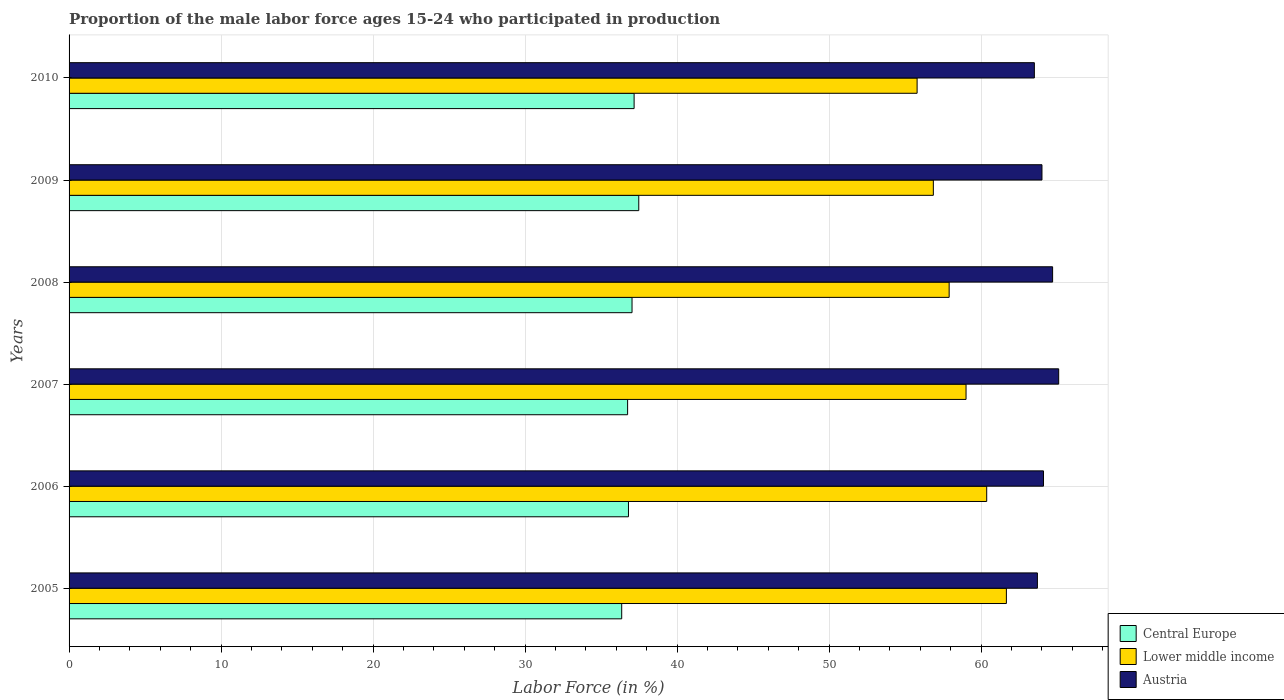How many different coloured bars are there?
Ensure brevity in your answer.  3. How many bars are there on the 5th tick from the top?
Provide a succinct answer. 3. What is the label of the 6th group of bars from the top?
Provide a short and direct response. 2005. In how many cases, is the number of bars for a given year not equal to the number of legend labels?
Offer a very short reply. 0. What is the proportion of the male labor force who participated in production in Lower middle income in 2010?
Your answer should be very brief. 55.79. Across all years, what is the maximum proportion of the male labor force who participated in production in Central Europe?
Make the answer very short. 37.48. Across all years, what is the minimum proportion of the male labor force who participated in production in Austria?
Keep it short and to the point. 63.5. In which year was the proportion of the male labor force who participated in production in Central Europe maximum?
Your response must be concise. 2009. In which year was the proportion of the male labor force who participated in production in Central Europe minimum?
Keep it short and to the point. 2005. What is the total proportion of the male labor force who participated in production in Austria in the graph?
Provide a succinct answer. 385.1. What is the difference between the proportion of the male labor force who participated in production in Lower middle income in 2006 and that in 2009?
Offer a very short reply. 3.51. What is the difference between the proportion of the male labor force who participated in production in Lower middle income in 2006 and the proportion of the male labor force who participated in production in Central Europe in 2008?
Provide a succinct answer. 23.33. What is the average proportion of the male labor force who participated in production in Austria per year?
Your answer should be compact. 64.18. In the year 2006, what is the difference between the proportion of the male labor force who participated in production in Central Europe and proportion of the male labor force who participated in production in Austria?
Ensure brevity in your answer.  -27.3. In how many years, is the proportion of the male labor force who participated in production in Lower middle income greater than 38 %?
Your answer should be compact. 6. What is the ratio of the proportion of the male labor force who participated in production in Lower middle income in 2009 to that in 2010?
Provide a succinct answer. 1.02. Is the difference between the proportion of the male labor force who participated in production in Central Europe in 2005 and 2006 greater than the difference between the proportion of the male labor force who participated in production in Austria in 2005 and 2006?
Offer a very short reply. No. What is the difference between the highest and the second highest proportion of the male labor force who participated in production in Central Europe?
Provide a short and direct response. 0.31. What is the difference between the highest and the lowest proportion of the male labor force who participated in production in Lower middle income?
Offer a very short reply. 5.87. Is the sum of the proportion of the male labor force who participated in production in Austria in 2008 and 2009 greater than the maximum proportion of the male labor force who participated in production in Central Europe across all years?
Provide a succinct answer. Yes. What does the 1st bar from the top in 2010 represents?
Make the answer very short. Austria. What does the 1st bar from the bottom in 2007 represents?
Offer a very short reply. Central Europe. How many bars are there?
Your response must be concise. 18. How many years are there in the graph?
Offer a very short reply. 6. What is the difference between two consecutive major ticks on the X-axis?
Offer a very short reply. 10. What is the title of the graph?
Ensure brevity in your answer.  Proportion of the male labor force ages 15-24 who participated in production. What is the label or title of the X-axis?
Give a very brief answer. Labor Force (in %). What is the Labor Force (in %) of Central Europe in 2005?
Provide a succinct answer. 36.35. What is the Labor Force (in %) in Lower middle income in 2005?
Give a very brief answer. 61.66. What is the Labor Force (in %) in Austria in 2005?
Keep it short and to the point. 63.7. What is the Labor Force (in %) in Central Europe in 2006?
Make the answer very short. 36.8. What is the Labor Force (in %) in Lower middle income in 2006?
Offer a terse response. 60.37. What is the Labor Force (in %) of Austria in 2006?
Make the answer very short. 64.1. What is the Labor Force (in %) in Central Europe in 2007?
Offer a very short reply. 36.74. What is the Labor Force (in %) of Lower middle income in 2007?
Keep it short and to the point. 59.01. What is the Labor Force (in %) in Austria in 2007?
Ensure brevity in your answer.  65.1. What is the Labor Force (in %) in Central Europe in 2008?
Your answer should be compact. 37.03. What is the Labor Force (in %) of Lower middle income in 2008?
Your answer should be very brief. 57.9. What is the Labor Force (in %) in Austria in 2008?
Your answer should be very brief. 64.7. What is the Labor Force (in %) in Central Europe in 2009?
Provide a succinct answer. 37.48. What is the Labor Force (in %) of Lower middle income in 2009?
Make the answer very short. 56.86. What is the Labor Force (in %) of Central Europe in 2010?
Your response must be concise. 37.17. What is the Labor Force (in %) in Lower middle income in 2010?
Keep it short and to the point. 55.79. What is the Labor Force (in %) of Austria in 2010?
Your answer should be very brief. 63.5. Across all years, what is the maximum Labor Force (in %) of Central Europe?
Your answer should be compact. 37.48. Across all years, what is the maximum Labor Force (in %) of Lower middle income?
Your answer should be compact. 61.66. Across all years, what is the maximum Labor Force (in %) of Austria?
Ensure brevity in your answer.  65.1. Across all years, what is the minimum Labor Force (in %) of Central Europe?
Ensure brevity in your answer.  36.35. Across all years, what is the minimum Labor Force (in %) in Lower middle income?
Your answer should be very brief. 55.79. Across all years, what is the minimum Labor Force (in %) of Austria?
Your answer should be compact. 63.5. What is the total Labor Force (in %) of Central Europe in the graph?
Keep it short and to the point. 221.58. What is the total Labor Force (in %) of Lower middle income in the graph?
Give a very brief answer. 351.57. What is the total Labor Force (in %) in Austria in the graph?
Keep it short and to the point. 385.1. What is the difference between the Labor Force (in %) in Central Europe in 2005 and that in 2006?
Ensure brevity in your answer.  -0.44. What is the difference between the Labor Force (in %) in Lower middle income in 2005 and that in 2006?
Your answer should be very brief. 1.29. What is the difference between the Labor Force (in %) of Central Europe in 2005 and that in 2007?
Ensure brevity in your answer.  -0.39. What is the difference between the Labor Force (in %) in Lower middle income in 2005 and that in 2007?
Provide a succinct answer. 2.65. What is the difference between the Labor Force (in %) of Central Europe in 2005 and that in 2008?
Your response must be concise. -0.68. What is the difference between the Labor Force (in %) of Lower middle income in 2005 and that in 2008?
Ensure brevity in your answer.  3.77. What is the difference between the Labor Force (in %) in Central Europe in 2005 and that in 2009?
Make the answer very short. -1.12. What is the difference between the Labor Force (in %) in Lower middle income in 2005 and that in 2009?
Your answer should be very brief. 4.81. What is the difference between the Labor Force (in %) of Austria in 2005 and that in 2009?
Offer a terse response. -0.3. What is the difference between the Labor Force (in %) in Central Europe in 2005 and that in 2010?
Ensure brevity in your answer.  -0.82. What is the difference between the Labor Force (in %) of Lower middle income in 2005 and that in 2010?
Offer a terse response. 5.87. What is the difference between the Labor Force (in %) in Central Europe in 2006 and that in 2007?
Your answer should be very brief. 0.06. What is the difference between the Labor Force (in %) in Lower middle income in 2006 and that in 2007?
Provide a succinct answer. 1.36. What is the difference between the Labor Force (in %) of Austria in 2006 and that in 2007?
Give a very brief answer. -1. What is the difference between the Labor Force (in %) of Central Europe in 2006 and that in 2008?
Your answer should be very brief. -0.23. What is the difference between the Labor Force (in %) in Lower middle income in 2006 and that in 2008?
Your answer should be compact. 2.47. What is the difference between the Labor Force (in %) of Austria in 2006 and that in 2008?
Provide a succinct answer. -0.6. What is the difference between the Labor Force (in %) of Central Europe in 2006 and that in 2009?
Your answer should be compact. -0.68. What is the difference between the Labor Force (in %) in Lower middle income in 2006 and that in 2009?
Provide a succinct answer. 3.51. What is the difference between the Labor Force (in %) in Central Europe in 2006 and that in 2010?
Provide a short and direct response. -0.37. What is the difference between the Labor Force (in %) in Lower middle income in 2006 and that in 2010?
Offer a terse response. 4.58. What is the difference between the Labor Force (in %) in Central Europe in 2007 and that in 2008?
Your answer should be very brief. -0.29. What is the difference between the Labor Force (in %) in Austria in 2007 and that in 2008?
Provide a succinct answer. 0.4. What is the difference between the Labor Force (in %) of Central Europe in 2007 and that in 2009?
Your answer should be compact. -0.73. What is the difference between the Labor Force (in %) of Lower middle income in 2007 and that in 2009?
Keep it short and to the point. 2.15. What is the difference between the Labor Force (in %) in Austria in 2007 and that in 2009?
Your answer should be compact. 1.1. What is the difference between the Labor Force (in %) in Central Europe in 2007 and that in 2010?
Ensure brevity in your answer.  -0.43. What is the difference between the Labor Force (in %) in Lower middle income in 2007 and that in 2010?
Offer a very short reply. 3.22. What is the difference between the Labor Force (in %) of Austria in 2007 and that in 2010?
Make the answer very short. 1.6. What is the difference between the Labor Force (in %) of Central Europe in 2008 and that in 2009?
Give a very brief answer. -0.44. What is the difference between the Labor Force (in %) in Austria in 2008 and that in 2009?
Your response must be concise. 0.7. What is the difference between the Labor Force (in %) in Central Europe in 2008 and that in 2010?
Offer a terse response. -0.14. What is the difference between the Labor Force (in %) of Lower middle income in 2008 and that in 2010?
Your answer should be very brief. 2.11. What is the difference between the Labor Force (in %) in Austria in 2008 and that in 2010?
Make the answer very short. 1.2. What is the difference between the Labor Force (in %) of Central Europe in 2009 and that in 2010?
Your response must be concise. 0.31. What is the difference between the Labor Force (in %) in Lower middle income in 2009 and that in 2010?
Offer a very short reply. 1.07. What is the difference between the Labor Force (in %) of Central Europe in 2005 and the Labor Force (in %) of Lower middle income in 2006?
Provide a succinct answer. -24.01. What is the difference between the Labor Force (in %) in Central Europe in 2005 and the Labor Force (in %) in Austria in 2006?
Make the answer very short. -27.75. What is the difference between the Labor Force (in %) in Lower middle income in 2005 and the Labor Force (in %) in Austria in 2006?
Your response must be concise. -2.44. What is the difference between the Labor Force (in %) in Central Europe in 2005 and the Labor Force (in %) in Lower middle income in 2007?
Provide a succinct answer. -22.65. What is the difference between the Labor Force (in %) in Central Europe in 2005 and the Labor Force (in %) in Austria in 2007?
Give a very brief answer. -28.75. What is the difference between the Labor Force (in %) of Lower middle income in 2005 and the Labor Force (in %) of Austria in 2007?
Give a very brief answer. -3.44. What is the difference between the Labor Force (in %) of Central Europe in 2005 and the Labor Force (in %) of Lower middle income in 2008?
Your response must be concise. -21.54. What is the difference between the Labor Force (in %) of Central Europe in 2005 and the Labor Force (in %) of Austria in 2008?
Provide a short and direct response. -28.35. What is the difference between the Labor Force (in %) in Lower middle income in 2005 and the Labor Force (in %) in Austria in 2008?
Make the answer very short. -3.04. What is the difference between the Labor Force (in %) in Central Europe in 2005 and the Labor Force (in %) in Lower middle income in 2009?
Keep it short and to the point. -20.5. What is the difference between the Labor Force (in %) in Central Europe in 2005 and the Labor Force (in %) in Austria in 2009?
Keep it short and to the point. -27.65. What is the difference between the Labor Force (in %) in Lower middle income in 2005 and the Labor Force (in %) in Austria in 2009?
Offer a terse response. -2.34. What is the difference between the Labor Force (in %) in Central Europe in 2005 and the Labor Force (in %) in Lower middle income in 2010?
Keep it short and to the point. -19.43. What is the difference between the Labor Force (in %) of Central Europe in 2005 and the Labor Force (in %) of Austria in 2010?
Provide a short and direct response. -27.15. What is the difference between the Labor Force (in %) in Lower middle income in 2005 and the Labor Force (in %) in Austria in 2010?
Give a very brief answer. -1.84. What is the difference between the Labor Force (in %) in Central Europe in 2006 and the Labor Force (in %) in Lower middle income in 2007?
Offer a terse response. -22.21. What is the difference between the Labor Force (in %) of Central Europe in 2006 and the Labor Force (in %) of Austria in 2007?
Offer a very short reply. -28.3. What is the difference between the Labor Force (in %) of Lower middle income in 2006 and the Labor Force (in %) of Austria in 2007?
Your answer should be very brief. -4.73. What is the difference between the Labor Force (in %) of Central Europe in 2006 and the Labor Force (in %) of Lower middle income in 2008?
Provide a succinct answer. -21.1. What is the difference between the Labor Force (in %) of Central Europe in 2006 and the Labor Force (in %) of Austria in 2008?
Ensure brevity in your answer.  -27.9. What is the difference between the Labor Force (in %) of Lower middle income in 2006 and the Labor Force (in %) of Austria in 2008?
Keep it short and to the point. -4.33. What is the difference between the Labor Force (in %) of Central Europe in 2006 and the Labor Force (in %) of Lower middle income in 2009?
Make the answer very short. -20.06. What is the difference between the Labor Force (in %) of Central Europe in 2006 and the Labor Force (in %) of Austria in 2009?
Offer a terse response. -27.2. What is the difference between the Labor Force (in %) of Lower middle income in 2006 and the Labor Force (in %) of Austria in 2009?
Your answer should be very brief. -3.63. What is the difference between the Labor Force (in %) of Central Europe in 2006 and the Labor Force (in %) of Lower middle income in 2010?
Offer a terse response. -18.99. What is the difference between the Labor Force (in %) of Central Europe in 2006 and the Labor Force (in %) of Austria in 2010?
Your answer should be very brief. -26.7. What is the difference between the Labor Force (in %) of Lower middle income in 2006 and the Labor Force (in %) of Austria in 2010?
Provide a succinct answer. -3.13. What is the difference between the Labor Force (in %) of Central Europe in 2007 and the Labor Force (in %) of Lower middle income in 2008?
Keep it short and to the point. -21.15. What is the difference between the Labor Force (in %) in Central Europe in 2007 and the Labor Force (in %) in Austria in 2008?
Your answer should be compact. -27.96. What is the difference between the Labor Force (in %) in Lower middle income in 2007 and the Labor Force (in %) in Austria in 2008?
Your answer should be compact. -5.69. What is the difference between the Labor Force (in %) of Central Europe in 2007 and the Labor Force (in %) of Lower middle income in 2009?
Provide a succinct answer. -20.11. What is the difference between the Labor Force (in %) in Central Europe in 2007 and the Labor Force (in %) in Austria in 2009?
Your answer should be very brief. -27.26. What is the difference between the Labor Force (in %) of Lower middle income in 2007 and the Labor Force (in %) of Austria in 2009?
Keep it short and to the point. -4.99. What is the difference between the Labor Force (in %) in Central Europe in 2007 and the Labor Force (in %) in Lower middle income in 2010?
Your answer should be very brief. -19.04. What is the difference between the Labor Force (in %) in Central Europe in 2007 and the Labor Force (in %) in Austria in 2010?
Your answer should be very brief. -26.76. What is the difference between the Labor Force (in %) of Lower middle income in 2007 and the Labor Force (in %) of Austria in 2010?
Offer a very short reply. -4.49. What is the difference between the Labor Force (in %) of Central Europe in 2008 and the Labor Force (in %) of Lower middle income in 2009?
Your answer should be compact. -19.82. What is the difference between the Labor Force (in %) in Central Europe in 2008 and the Labor Force (in %) in Austria in 2009?
Make the answer very short. -26.97. What is the difference between the Labor Force (in %) in Lower middle income in 2008 and the Labor Force (in %) in Austria in 2009?
Keep it short and to the point. -6.11. What is the difference between the Labor Force (in %) of Central Europe in 2008 and the Labor Force (in %) of Lower middle income in 2010?
Keep it short and to the point. -18.75. What is the difference between the Labor Force (in %) in Central Europe in 2008 and the Labor Force (in %) in Austria in 2010?
Offer a very short reply. -26.47. What is the difference between the Labor Force (in %) in Lower middle income in 2008 and the Labor Force (in %) in Austria in 2010?
Your response must be concise. -5.61. What is the difference between the Labor Force (in %) in Central Europe in 2009 and the Labor Force (in %) in Lower middle income in 2010?
Give a very brief answer. -18.31. What is the difference between the Labor Force (in %) in Central Europe in 2009 and the Labor Force (in %) in Austria in 2010?
Your answer should be compact. -26.02. What is the difference between the Labor Force (in %) of Lower middle income in 2009 and the Labor Force (in %) of Austria in 2010?
Provide a short and direct response. -6.64. What is the average Labor Force (in %) in Central Europe per year?
Ensure brevity in your answer.  36.93. What is the average Labor Force (in %) of Lower middle income per year?
Make the answer very short. 58.59. What is the average Labor Force (in %) of Austria per year?
Your response must be concise. 64.18. In the year 2005, what is the difference between the Labor Force (in %) of Central Europe and Labor Force (in %) of Lower middle income?
Keep it short and to the point. -25.31. In the year 2005, what is the difference between the Labor Force (in %) in Central Europe and Labor Force (in %) in Austria?
Offer a terse response. -27.35. In the year 2005, what is the difference between the Labor Force (in %) of Lower middle income and Labor Force (in %) of Austria?
Offer a terse response. -2.04. In the year 2006, what is the difference between the Labor Force (in %) of Central Europe and Labor Force (in %) of Lower middle income?
Give a very brief answer. -23.57. In the year 2006, what is the difference between the Labor Force (in %) of Central Europe and Labor Force (in %) of Austria?
Ensure brevity in your answer.  -27.3. In the year 2006, what is the difference between the Labor Force (in %) of Lower middle income and Labor Force (in %) of Austria?
Offer a terse response. -3.73. In the year 2007, what is the difference between the Labor Force (in %) in Central Europe and Labor Force (in %) in Lower middle income?
Make the answer very short. -22.26. In the year 2007, what is the difference between the Labor Force (in %) of Central Europe and Labor Force (in %) of Austria?
Give a very brief answer. -28.36. In the year 2007, what is the difference between the Labor Force (in %) in Lower middle income and Labor Force (in %) in Austria?
Offer a very short reply. -6.09. In the year 2008, what is the difference between the Labor Force (in %) in Central Europe and Labor Force (in %) in Lower middle income?
Give a very brief answer. -20.86. In the year 2008, what is the difference between the Labor Force (in %) of Central Europe and Labor Force (in %) of Austria?
Make the answer very short. -27.67. In the year 2008, what is the difference between the Labor Force (in %) in Lower middle income and Labor Force (in %) in Austria?
Provide a succinct answer. -6.8. In the year 2009, what is the difference between the Labor Force (in %) in Central Europe and Labor Force (in %) in Lower middle income?
Ensure brevity in your answer.  -19.38. In the year 2009, what is the difference between the Labor Force (in %) of Central Europe and Labor Force (in %) of Austria?
Provide a succinct answer. -26.52. In the year 2009, what is the difference between the Labor Force (in %) in Lower middle income and Labor Force (in %) in Austria?
Keep it short and to the point. -7.14. In the year 2010, what is the difference between the Labor Force (in %) in Central Europe and Labor Force (in %) in Lower middle income?
Your answer should be very brief. -18.62. In the year 2010, what is the difference between the Labor Force (in %) of Central Europe and Labor Force (in %) of Austria?
Provide a succinct answer. -26.33. In the year 2010, what is the difference between the Labor Force (in %) in Lower middle income and Labor Force (in %) in Austria?
Offer a very short reply. -7.71. What is the ratio of the Labor Force (in %) of Central Europe in 2005 to that in 2006?
Give a very brief answer. 0.99. What is the ratio of the Labor Force (in %) of Lower middle income in 2005 to that in 2006?
Ensure brevity in your answer.  1.02. What is the ratio of the Labor Force (in %) of Austria in 2005 to that in 2006?
Make the answer very short. 0.99. What is the ratio of the Labor Force (in %) of Lower middle income in 2005 to that in 2007?
Provide a succinct answer. 1.04. What is the ratio of the Labor Force (in %) of Austria in 2005 to that in 2007?
Provide a short and direct response. 0.98. What is the ratio of the Labor Force (in %) in Central Europe in 2005 to that in 2008?
Provide a short and direct response. 0.98. What is the ratio of the Labor Force (in %) in Lower middle income in 2005 to that in 2008?
Make the answer very short. 1.06. What is the ratio of the Labor Force (in %) in Austria in 2005 to that in 2008?
Your answer should be compact. 0.98. What is the ratio of the Labor Force (in %) of Central Europe in 2005 to that in 2009?
Your answer should be very brief. 0.97. What is the ratio of the Labor Force (in %) of Lower middle income in 2005 to that in 2009?
Offer a very short reply. 1.08. What is the ratio of the Labor Force (in %) of Austria in 2005 to that in 2009?
Ensure brevity in your answer.  1. What is the ratio of the Labor Force (in %) of Lower middle income in 2005 to that in 2010?
Give a very brief answer. 1.11. What is the ratio of the Labor Force (in %) in Lower middle income in 2006 to that in 2007?
Your answer should be compact. 1.02. What is the ratio of the Labor Force (in %) in Austria in 2006 to that in 2007?
Offer a terse response. 0.98. What is the ratio of the Labor Force (in %) in Central Europe in 2006 to that in 2008?
Ensure brevity in your answer.  0.99. What is the ratio of the Labor Force (in %) of Lower middle income in 2006 to that in 2008?
Make the answer very short. 1.04. What is the ratio of the Labor Force (in %) in Austria in 2006 to that in 2008?
Keep it short and to the point. 0.99. What is the ratio of the Labor Force (in %) in Central Europe in 2006 to that in 2009?
Provide a short and direct response. 0.98. What is the ratio of the Labor Force (in %) in Lower middle income in 2006 to that in 2009?
Your answer should be very brief. 1.06. What is the ratio of the Labor Force (in %) in Austria in 2006 to that in 2009?
Offer a very short reply. 1. What is the ratio of the Labor Force (in %) in Lower middle income in 2006 to that in 2010?
Give a very brief answer. 1.08. What is the ratio of the Labor Force (in %) of Austria in 2006 to that in 2010?
Make the answer very short. 1.01. What is the ratio of the Labor Force (in %) of Central Europe in 2007 to that in 2008?
Make the answer very short. 0.99. What is the ratio of the Labor Force (in %) in Lower middle income in 2007 to that in 2008?
Your response must be concise. 1.02. What is the ratio of the Labor Force (in %) of Central Europe in 2007 to that in 2009?
Ensure brevity in your answer.  0.98. What is the ratio of the Labor Force (in %) of Lower middle income in 2007 to that in 2009?
Your answer should be compact. 1.04. What is the ratio of the Labor Force (in %) of Austria in 2007 to that in 2009?
Make the answer very short. 1.02. What is the ratio of the Labor Force (in %) in Lower middle income in 2007 to that in 2010?
Offer a terse response. 1.06. What is the ratio of the Labor Force (in %) of Austria in 2007 to that in 2010?
Your answer should be very brief. 1.03. What is the ratio of the Labor Force (in %) in Central Europe in 2008 to that in 2009?
Your response must be concise. 0.99. What is the ratio of the Labor Force (in %) in Lower middle income in 2008 to that in 2009?
Give a very brief answer. 1.02. What is the ratio of the Labor Force (in %) of Austria in 2008 to that in 2009?
Provide a short and direct response. 1.01. What is the ratio of the Labor Force (in %) of Lower middle income in 2008 to that in 2010?
Your answer should be compact. 1.04. What is the ratio of the Labor Force (in %) of Austria in 2008 to that in 2010?
Your answer should be very brief. 1.02. What is the ratio of the Labor Force (in %) of Central Europe in 2009 to that in 2010?
Give a very brief answer. 1.01. What is the ratio of the Labor Force (in %) of Lower middle income in 2009 to that in 2010?
Offer a terse response. 1.02. What is the ratio of the Labor Force (in %) of Austria in 2009 to that in 2010?
Your response must be concise. 1.01. What is the difference between the highest and the second highest Labor Force (in %) of Central Europe?
Ensure brevity in your answer.  0.31. What is the difference between the highest and the second highest Labor Force (in %) in Lower middle income?
Provide a succinct answer. 1.29. What is the difference between the highest and the lowest Labor Force (in %) of Central Europe?
Give a very brief answer. 1.12. What is the difference between the highest and the lowest Labor Force (in %) of Lower middle income?
Your answer should be compact. 5.87. 